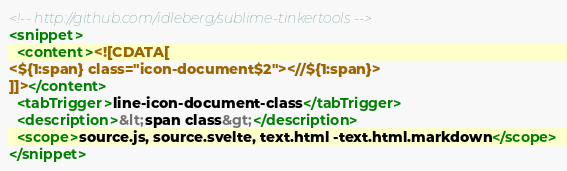Convert code to text. <code><loc_0><loc_0><loc_500><loc_500><_XML_><!-- http://github.com/idleberg/sublime-tinkertools -->
<snippet>
  <content><![CDATA[
<${1:span} class="icon-document$2"><//${1:span}>
]]></content>
  <tabTrigger>line-icon-document-class</tabTrigger>
  <description>&lt;span class&gt;</description>
  <scope>source.js, source.svelte, text.html -text.html.markdown</scope>
</snippet>
</code> 